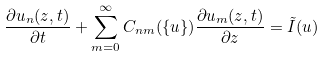Convert formula to latex. <formula><loc_0><loc_0><loc_500><loc_500>\frac { \partial u _ { n } ( z , t ) } { \partial t } + \sum _ { m = 0 } ^ { \infty } C _ { n m } ( \{ u \} ) \frac { \partial u _ { m } ( z , t ) } { \partial z } = \tilde { I } ( u )</formula> 